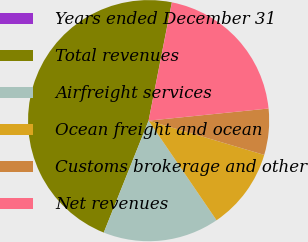Convert chart to OTSL. <chart><loc_0><loc_0><loc_500><loc_500><pie_chart><fcel>Years ended December 31<fcel>Total revenues<fcel>Airfreight services<fcel>Ocean freight and ocean<fcel>Customs brokerage and other<fcel>Net revenues<nl><fcel>0.02%<fcel>47.02%<fcel>15.59%<fcel>10.89%<fcel>6.19%<fcel>20.29%<nl></chart> 